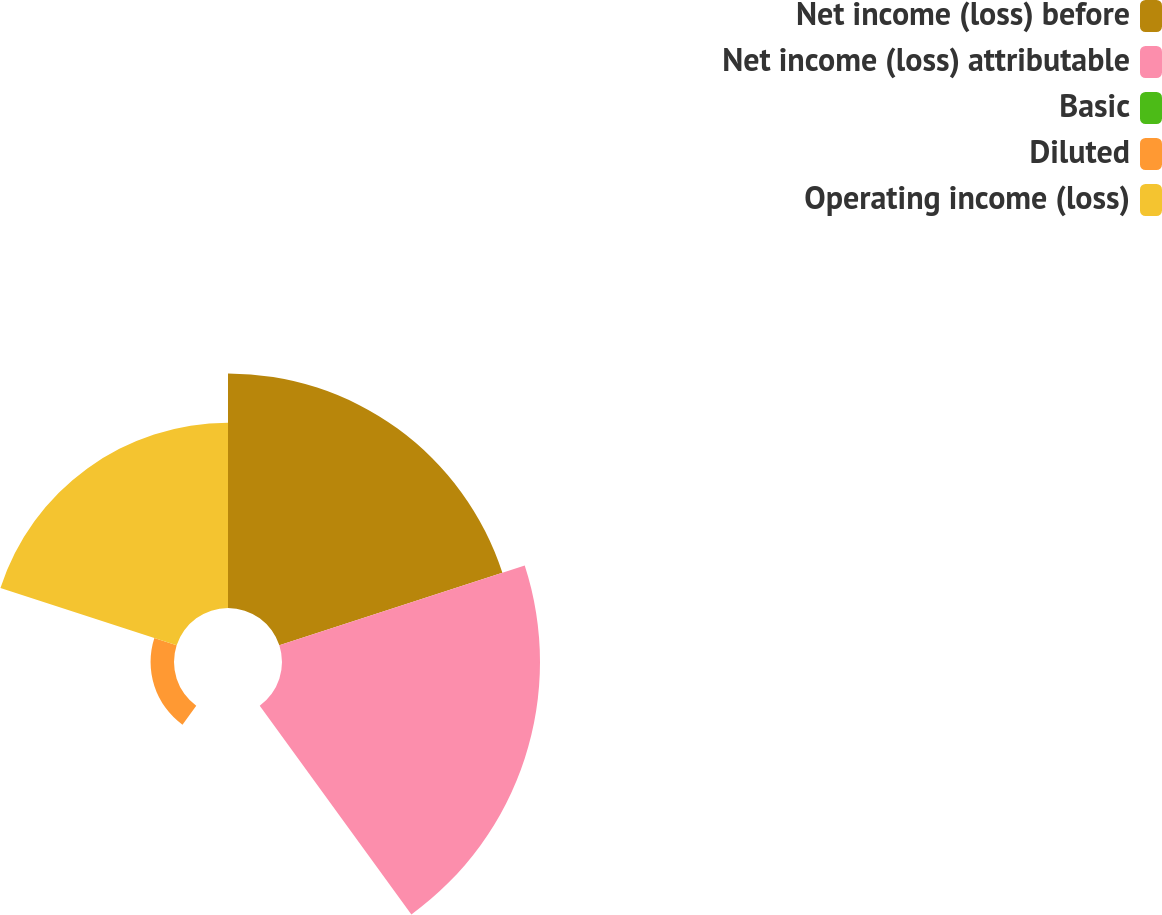<chart> <loc_0><loc_0><loc_500><loc_500><pie_chart><fcel>Net income (loss) before<fcel>Net income (loss) attributable<fcel>Basic<fcel>Diluted<fcel>Operating income (loss)<nl><fcel>33.44%<fcel>36.79%<fcel>0.0%<fcel>3.34%<fcel>26.42%<nl></chart> 